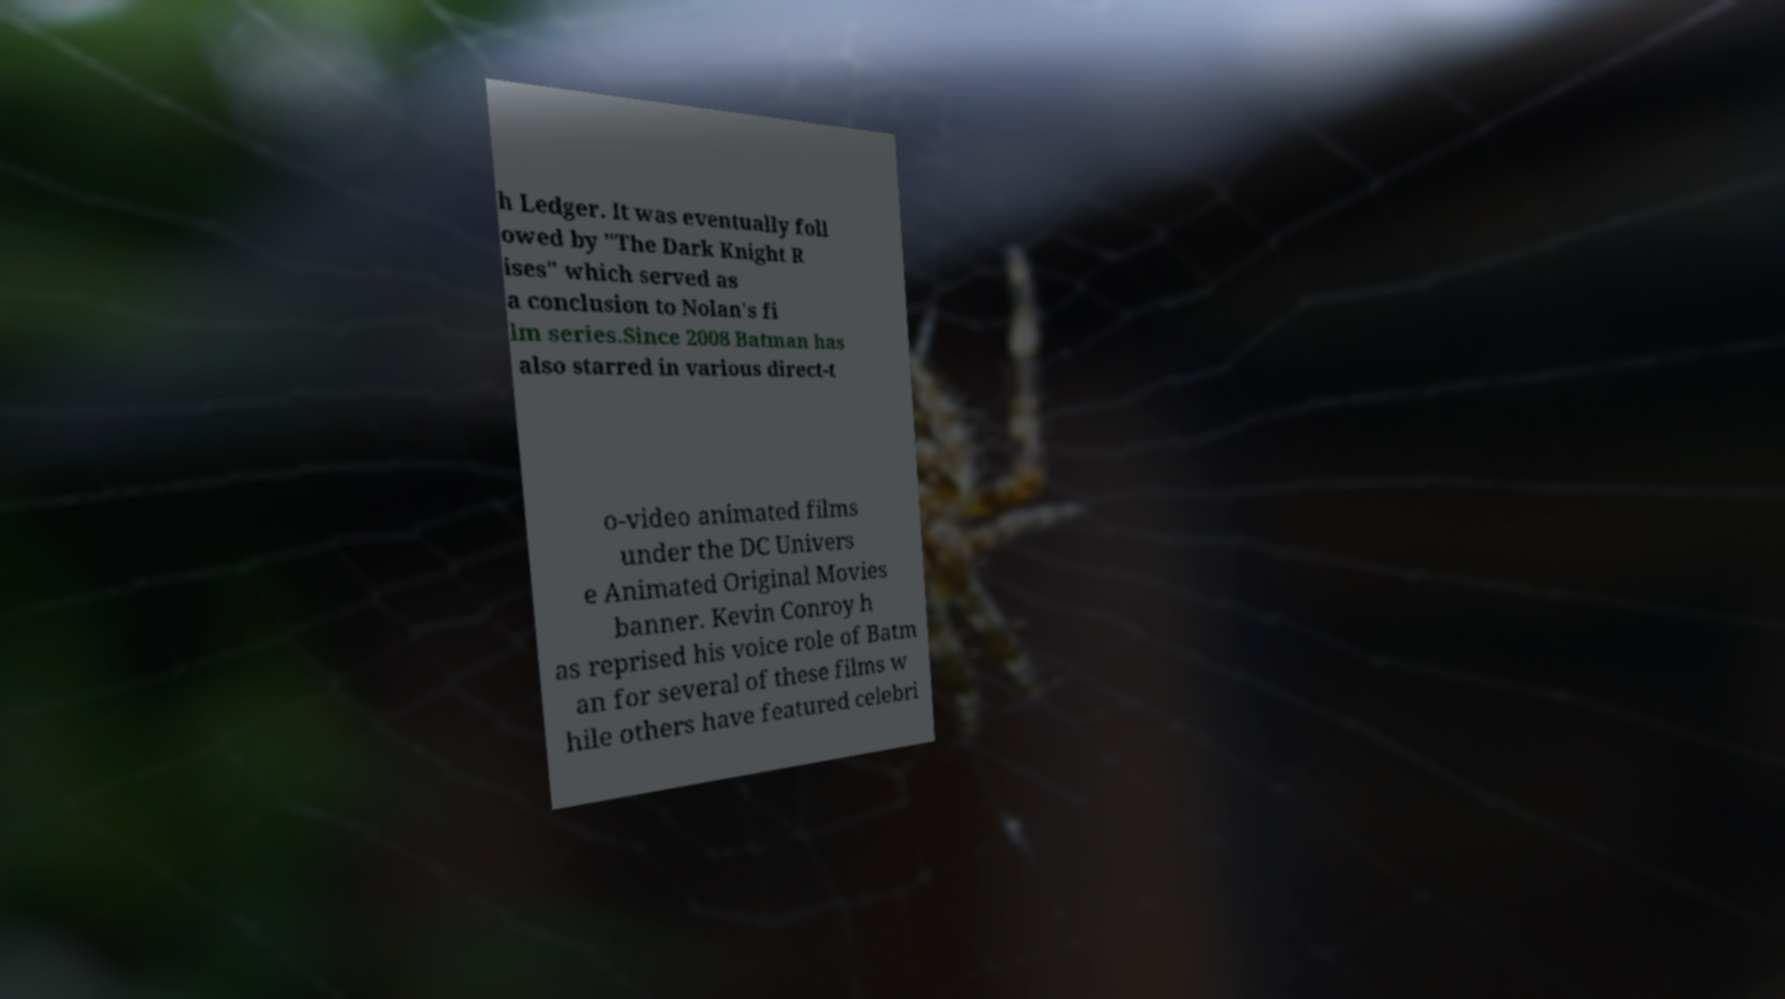What messages or text are displayed in this image? I need them in a readable, typed format. h Ledger. It was eventually foll owed by "The Dark Knight R ises" which served as a conclusion to Nolan's fi lm series.Since 2008 Batman has also starred in various direct-t o-video animated films under the DC Univers e Animated Original Movies banner. Kevin Conroy h as reprised his voice role of Batm an for several of these films w hile others have featured celebri 